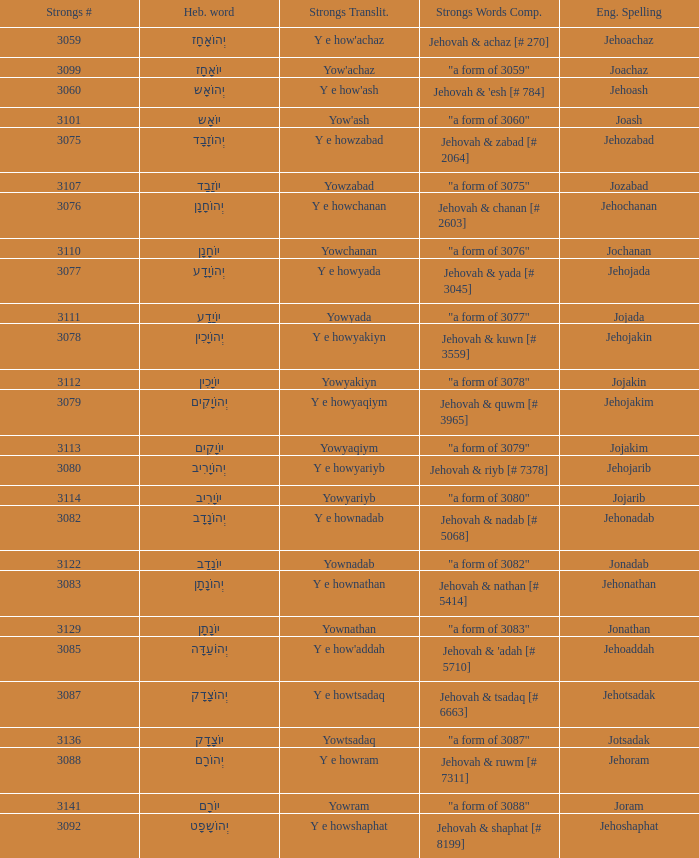Would you mind parsing the complete table? {'header': ['Strongs #', 'Heb. word', 'Strongs Translit.', 'Strongs Words Comp.', 'Eng. Spelling'], 'rows': [['3059', 'יְהוֹאָחָז', "Y e how'achaz", 'Jehovah & achaz [# 270]', 'Jehoachaz'], ['3099', 'יוֹאָחָז', "Yow'achaz", '"a form of 3059"', 'Joachaz'], ['3060', 'יְהוֹאָש', "Y e how'ash", "Jehovah & 'esh [# 784]", 'Jehoash'], ['3101', 'יוֹאָש', "Yow'ash", '"a form of 3060"', 'Joash'], ['3075', 'יְהוֹזָבָד', 'Y e howzabad', 'Jehovah & zabad [# 2064]', 'Jehozabad'], ['3107', 'יוֹזָבָד', 'Yowzabad', '"a form of 3075"', 'Jozabad'], ['3076', 'יְהוֹחָנָן', 'Y e howchanan', 'Jehovah & chanan [# 2603]', 'Jehochanan'], ['3110', 'יוֹחָנָן', 'Yowchanan', '"a form of 3076"', 'Jochanan'], ['3077', 'יְהוֹיָדָע', 'Y e howyada', 'Jehovah & yada [# 3045]', 'Jehojada'], ['3111', 'יוֹיָדָע', 'Yowyada', '"a form of 3077"', 'Jojada'], ['3078', 'יְהוֹיָכִין', 'Y e howyakiyn', 'Jehovah & kuwn [# 3559]', 'Jehojakin'], ['3112', 'יוֹיָכִין', 'Yowyakiyn', '"a form of 3078"', 'Jojakin'], ['3079', 'יְהוֹיָקִים', 'Y e howyaqiym', 'Jehovah & quwm [# 3965]', 'Jehojakim'], ['3113', 'יוֹיָקִים', 'Yowyaqiym', '"a form of 3079"', 'Jojakim'], ['3080', 'יְהוֹיָרִיב', 'Y e howyariyb', 'Jehovah & riyb [# 7378]', 'Jehojarib'], ['3114', 'יוֹיָרִיב', 'Yowyariyb', '"a form of 3080"', 'Jojarib'], ['3082', 'יְהוֹנָדָב', 'Y e hownadab', 'Jehovah & nadab [# 5068]', 'Jehonadab'], ['3122', 'יוֹנָדָב', 'Yownadab', '"a form of 3082"', 'Jonadab'], ['3083', 'יְהוֹנָתָן', 'Y e hownathan', 'Jehovah & nathan [# 5414]', 'Jehonathan'], ['3129', 'יוֹנָתָן', 'Yownathan', '"a form of 3083"', 'Jonathan'], ['3085', 'יְהוֹעַדָּה', "Y e how'addah", "Jehovah & 'adah [# 5710]", 'Jehoaddah'], ['3087', 'יְהוֹצָדָק', 'Y e howtsadaq', 'Jehovah & tsadaq [# 6663]', 'Jehotsadak'], ['3136', 'יוֹצָדָק', 'Yowtsadaq', '"a form of 3087"', 'Jotsadak'], ['3088', 'יְהוֹרָם', 'Y e howram', 'Jehovah & ruwm [# 7311]', 'Jehoram'], ['3141', 'יוֹרָם', 'Yowram', '"a form of 3088"', 'Joram'], ['3092', 'יְהוֹשָפָט', 'Y e howshaphat', 'Jehovah & shaphat [# 8199]', 'Jehoshaphat']]} What is the strongs # of the english spelling word jehojakin? 3078.0. 